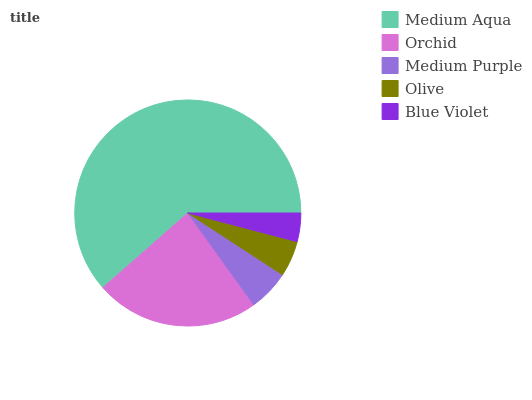Is Blue Violet the minimum?
Answer yes or no. Yes. Is Medium Aqua the maximum?
Answer yes or no. Yes. Is Orchid the minimum?
Answer yes or no. No. Is Orchid the maximum?
Answer yes or no. No. Is Medium Aqua greater than Orchid?
Answer yes or no. Yes. Is Orchid less than Medium Aqua?
Answer yes or no. Yes. Is Orchid greater than Medium Aqua?
Answer yes or no. No. Is Medium Aqua less than Orchid?
Answer yes or no. No. Is Medium Purple the high median?
Answer yes or no. Yes. Is Medium Purple the low median?
Answer yes or no. Yes. Is Blue Violet the high median?
Answer yes or no. No. Is Medium Aqua the low median?
Answer yes or no. No. 